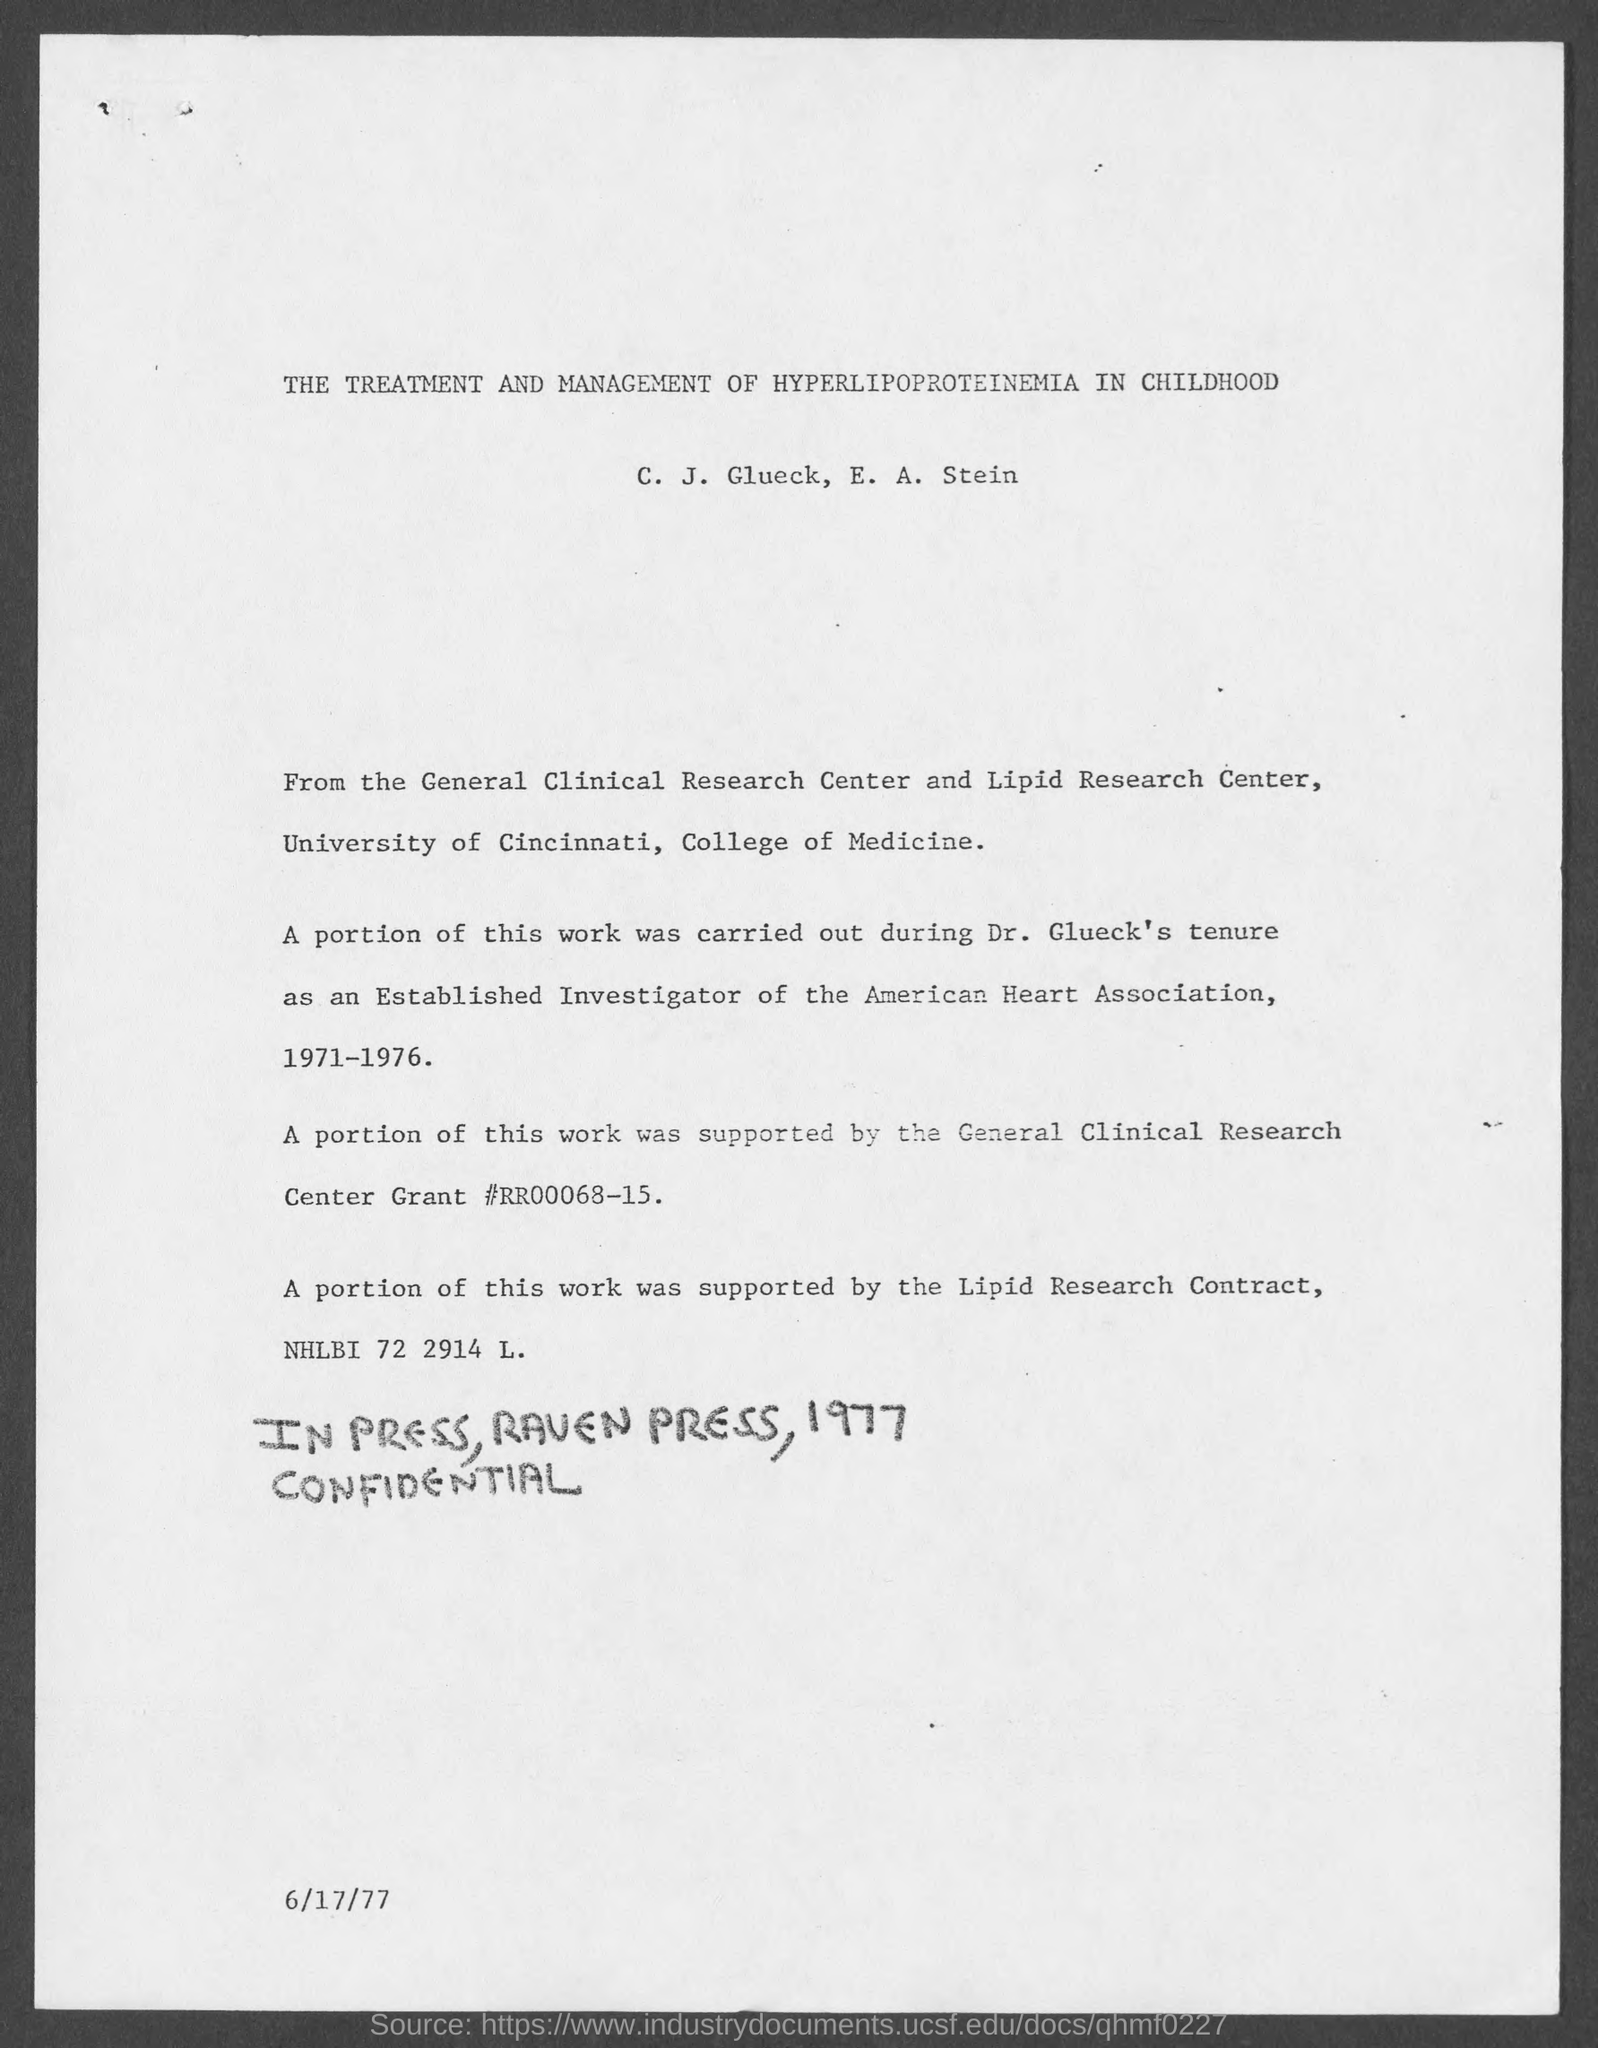What is the date at bottom of the page?
Your response must be concise. 6/17/77. 